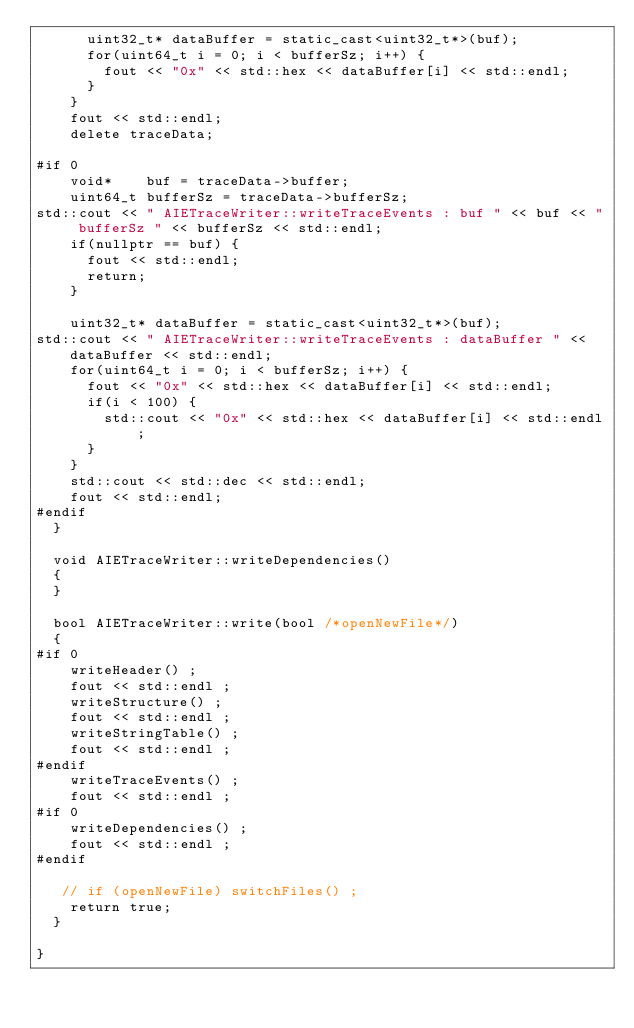<code> <loc_0><loc_0><loc_500><loc_500><_C++_>      uint32_t* dataBuffer = static_cast<uint32_t*>(buf);
      for(uint64_t i = 0; i < bufferSz; i++) {
        fout << "0x" << std::hex << dataBuffer[i] << std::endl;
      }
    }
    fout << std::endl;
    delete traceData;

#if 0
    void*    buf = traceData->buffer;
    uint64_t bufferSz = traceData->bufferSz;
std::cout << " AIETraceWriter::writeTraceEvents : buf " << buf << " bufferSz " << bufferSz << std::endl;
    if(nullptr == buf) {
      fout << std::endl;
      return;
    }

    uint32_t* dataBuffer = static_cast<uint32_t*>(buf);
std::cout << " AIETraceWriter::writeTraceEvents : dataBuffer " << dataBuffer << std::endl;
    for(uint64_t i = 0; i < bufferSz; i++) {
      fout << "0x" << std::hex << dataBuffer[i] << std::endl;
      if(i < 100) {
        std::cout << "0x" << std::hex << dataBuffer[i] << std::endl;
      }
    }
    std::cout << std::dec << std::endl;
    fout << std::endl;
#endif
  }

  void AIETraceWriter::writeDependencies()
  {
  }

  bool AIETraceWriter::write(bool /*openNewFile*/)
  {
#if 0
    writeHeader() ;
    fout << std::endl ;
    writeStructure() ;
    fout << std::endl ;
    writeStringTable() ;
    fout << std::endl ;
#endif
    writeTraceEvents() ;
    fout << std::endl ;
#if 0
    writeDependencies() ;
    fout << std::endl ;
#endif

   // if (openNewFile) switchFiles() ;
    return true;
  }

}
</code> 